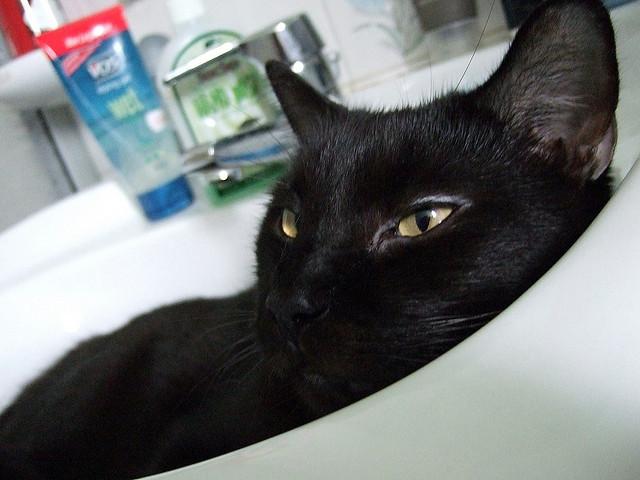Which animal is this?
Give a very brief answer. Cat. What color are the cat's eyes?
Be succinct. Yellow. Does this cat have any superstitions about it based on it's color?
Keep it brief. Yes. What is the cat laying in?
Be succinct. Sink. 